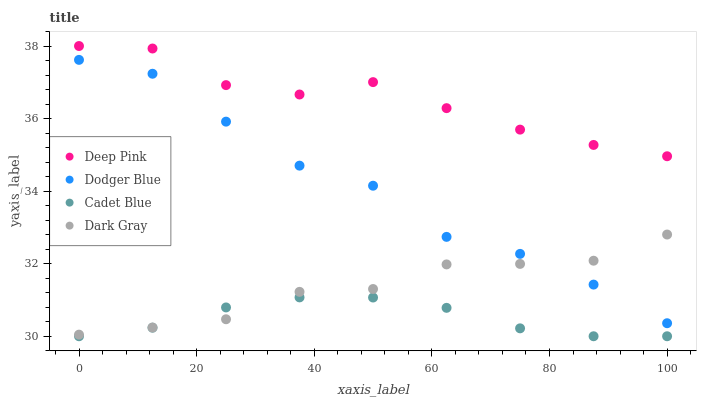Does Cadet Blue have the minimum area under the curve?
Answer yes or no. Yes. Does Deep Pink have the maximum area under the curve?
Answer yes or no. Yes. Does Dark Gray have the minimum area under the curve?
Answer yes or no. No. Does Dark Gray have the maximum area under the curve?
Answer yes or no. No. Is Cadet Blue the smoothest?
Answer yes or no. Yes. Is Dodger Blue the roughest?
Answer yes or no. Yes. Is Dark Gray the smoothest?
Answer yes or no. No. Is Dark Gray the roughest?
Answer yes or no. No. Does Cadet Blue have the lowest value?
Answer yes or no. Yes. Does Dark Gray have the lowest value?
Answer yes or no. No. Does Deep Pink have the highest value?
Answer yes or no. Yes. Does Dark Gray have the highest value?
Answer yes or no. No. Is Dodger Blue less than Deep Pink?
Answer yes or no. Yes. Is Deep Pink greater than Cadet Blue?
Answer yes or no. Yes. Does Cadet Blue intersect Dark Gray?
Answer yes or no. Yes. Is Cadet Blue less than Dark Gray?
Answer yes or no. No. Is Cadet Blue greater than Dark Gray?
Answer yes or no. No. Does Dodger Blue intersect Deep Pink?
Answer yes or no. No. 